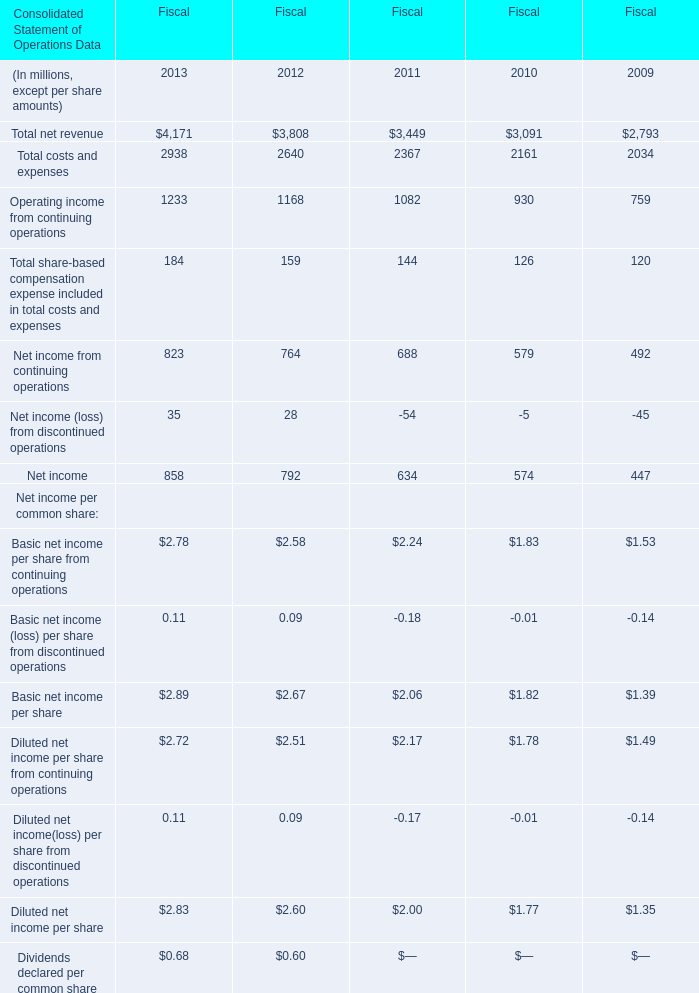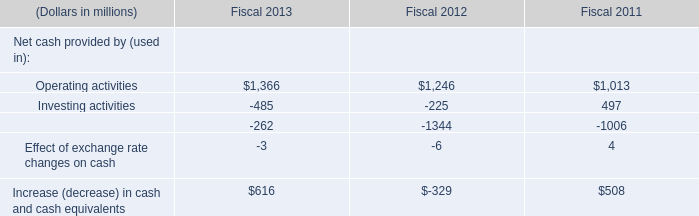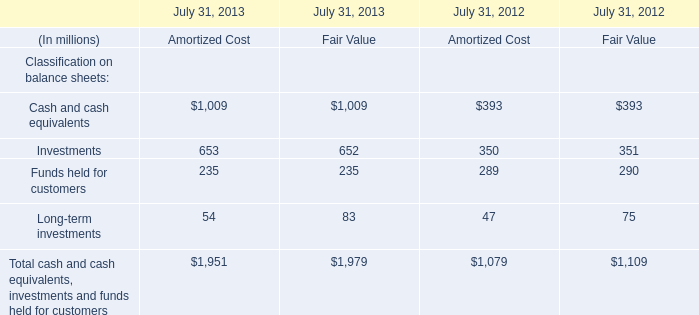What is the sum of Operating income from continuing operations, Net income from continuing operations and Net income (loss) from discontinued operations in 2013 in terms of Fiscal? (in million) 
Computations: ((1233 + 823) + 35)
Answer: 2091.0. 